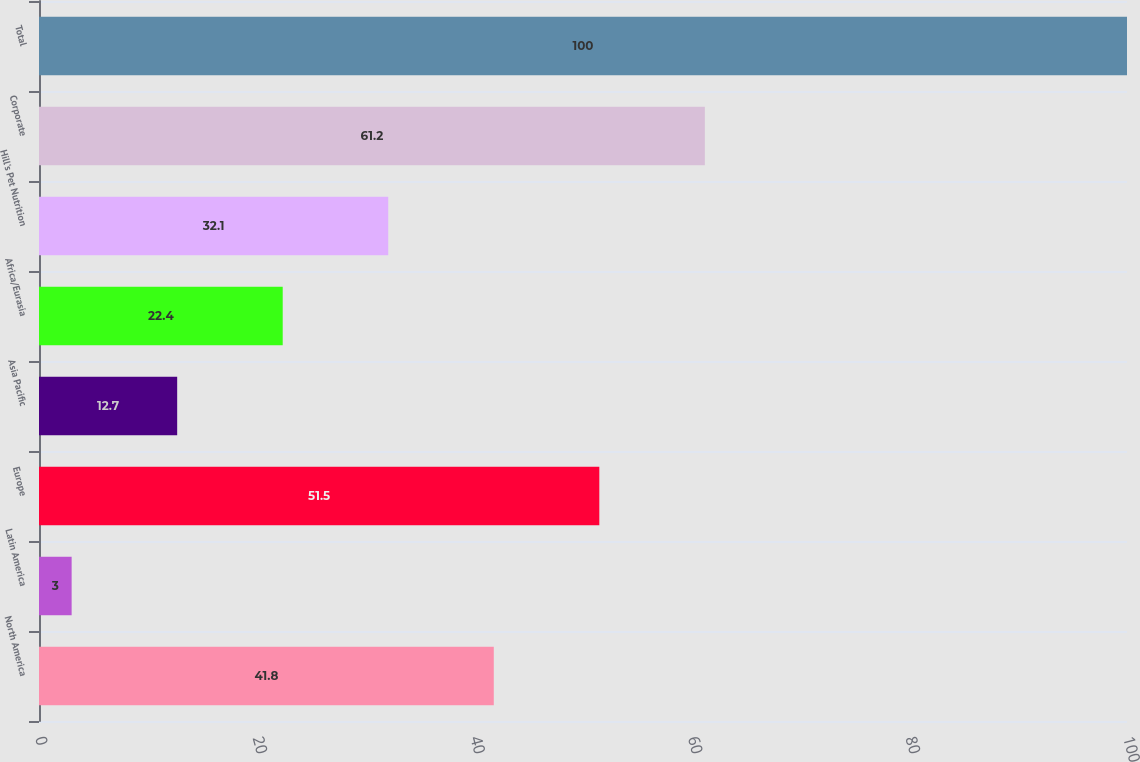<chart> <loc_0><loc_0><loc_500><loc_500><bar_chart><fcel>North America<fcel>Latin America<fcel>Europe<fcel>Asia Pacific<fcel>Africa/Eurasia<fcel>Hill's Pet Nutrition<fcel>Corporate<fcel>Total<nl><fcel>41.8<fcel>3<fcel>51.5<fcel>12.7<fcel>22.4<fcel>32.1<fcel>61.2<fcel>100<nl></chart> 